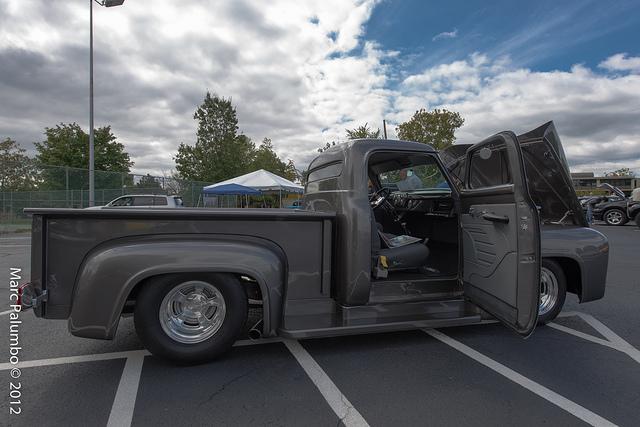Is the door of the truck closed?
Short answer required. No. Does this vehicle use gasoline to function?
Keep it brief. Yes. What color is the truck?
Concise answer only. Gray. 